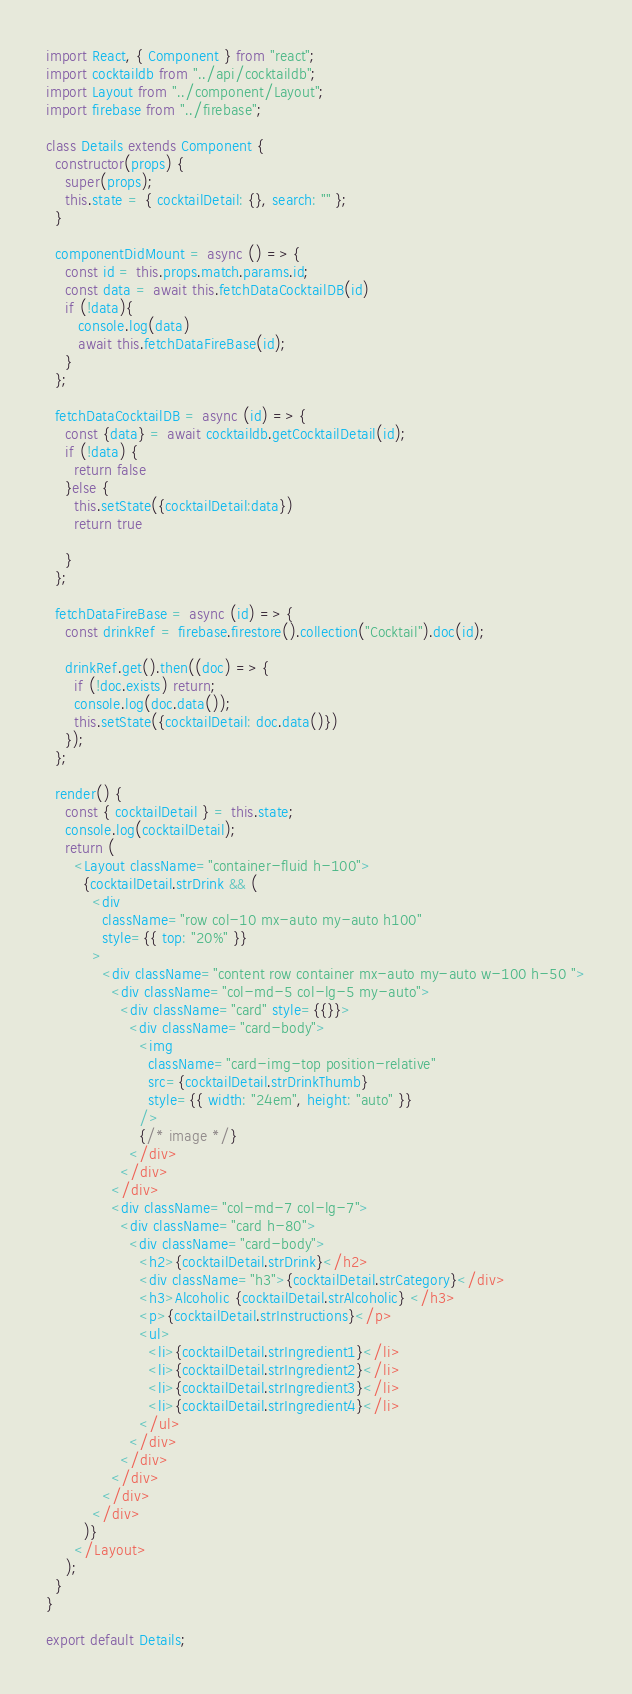<code> <loc_0><loc_0><loc_500><loc_500><_JavaScript_>import React, { Component } from "react";
import cocktaildb from "../api/cocktaildb";
import Layout from "../component/Layout";
import firebase from "../firebase";

class Details extends Component {
  constructor(props) {
    super(props);
    this.state = { cocktailDetail: {}, search: "" };
  }

  componentDidMount = async () => {
    const id = this.props.match.params.id;
    const data = await this.fetchDataCocktailDB(id)
    if (!data){
       console.log(data)
       await this.fetchDataFireBase(id);
    }
  };

  fetchDataCocktailDB = async (id) => {
    const {data} = await cocktaildb.getCocktailDetail(id);
    if (!data) {
      return false
    }else {
      this.setState({cocktailDetail:data})
      return true

    }
  };

  fetchDataFireBase = async (id) => {
    const drinkRef = firebase.firestore().collection("Cocktail").doc(id);

    drinkRef.get().then((doc) => {
      if (!doc.exists) return;
      console.log(doc.data());
      this.setState({cocktailDetail: doc.data()})
    });
  };

  render() {
    const { cocktailDetail } = this.state;
    console.log(cocktailDetail);
    return (
      <Layout className="container-fluid h-100">
        {cocktailDetail.strDrink && (
          <div
            className="row col-10 mx-auto my-auto h100"
            style={{ top: "20%" }}
          >
            <div className="content row container mx-auto my-auto w-100 h-50 ">
              <div className="col-md-5 col-lg-5 my-auto">
                <div className="card" style={{}}>
                  <div className="card-body">
                    <img
                      className="card-img-top position-relative"
                      src={cocktailDetail.strDrinkThumb}
                      style={{ width: "24em", height: "auto" }}
                    />
                    {/* image */}
                  </div>
                </div>
              </div>
              <div className="col-md-7 col-lg-7">
                <div className="card h-80">
                  <div className="card-body">
                    <h2>{cocktailDetail.strDrink}</h2>
                    <div className="h3">{cocktailDetail.strCategory}</div>
                    <h3>Alcoholic {cocktailDetail.strAlcoholic} </h3>
                    <p>{cocktailDetail.strInstructions}</p>
                    <ul>
                      <li>{cocktailDetail.strIngredient1}</li>
                      <li>{cocktailDetail.strIngredient2}</li>
                      <li>{cocktailDetail.strIngredient3}</li>
                      <li>{cocktailDetail.strIngredient4}</li>
                    </ul>
                  </div>
                </div>
              </div>
            </div>
          </div>
        )}
      </Layout>
    );
  }
}

export default Details;
</code> 